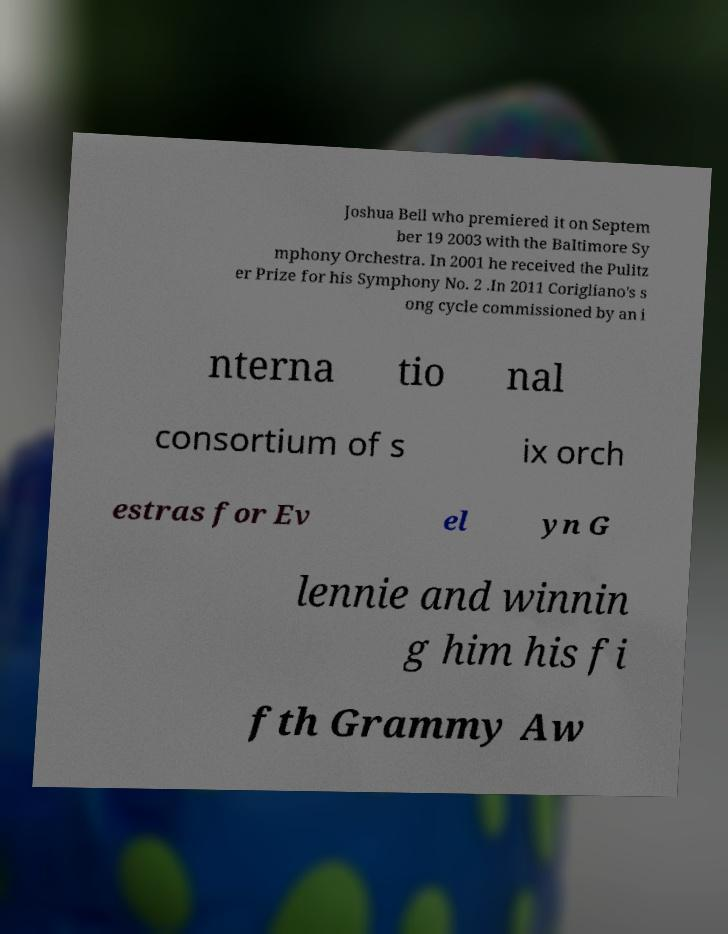Could you assist in decoding the text presented in this image and type it out clearly? Joshua Bell who premiered it on Septem ber 19 2003 with the Baltimore Sy mphony Orchestra. In 2001 he received the Pulitz er Prize for his Symphony No. 2 .In 2011 Corigliano's s ong cycle commissioned by an i nterna tio nal consortium of s ix orch estras for Ev el yn G lennie and winnin g him his fi fth Grammy Aw 